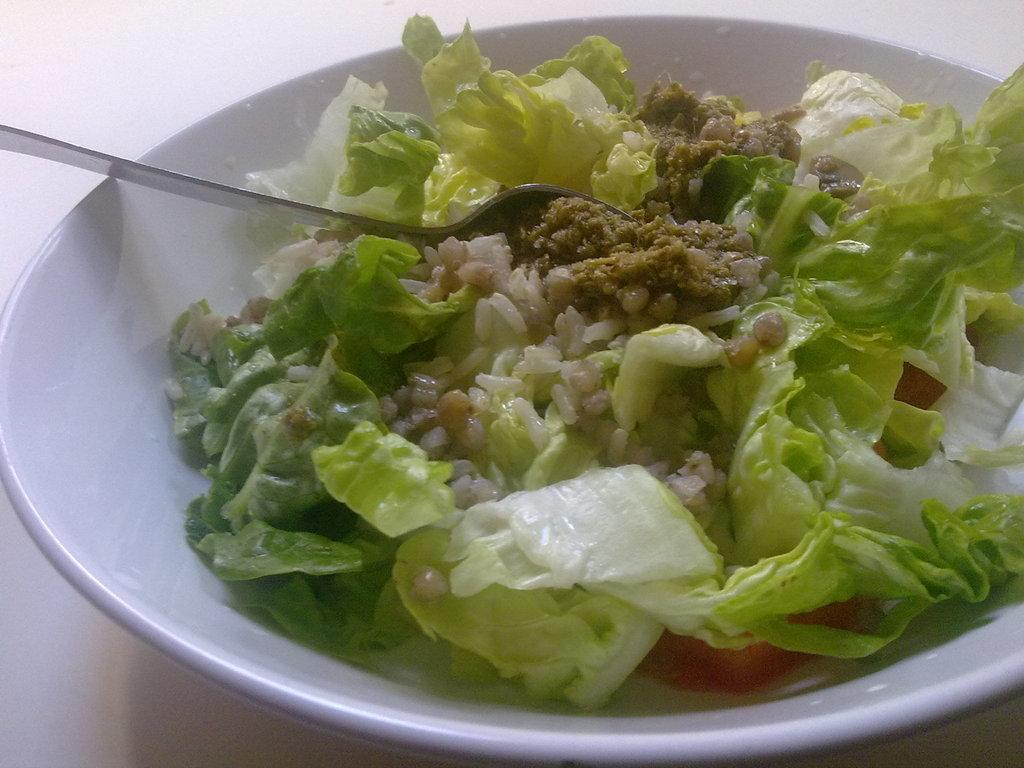What is the color of the bowl in the image? The bowl is white in color. What is inside the bowl in the image? There is a food item in the bowl. What utensil is present in the image? There is a spoon in the image. Can you read the writing on the bowl in the image? There is no writing present on the bowl in the image. How many ants can be seen carrying the food item in the bowl? There are no ants present in the image. 